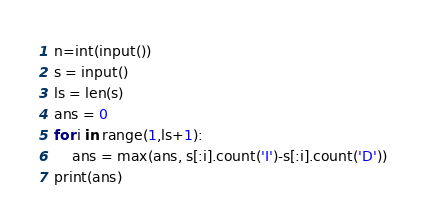<code> <loc_0><loc_0><loc_500><loc_500><_Python_>n=int(input())
s = input()
ls = len(s)
ans = 0
for i in range(1,ls+1):
    ans = max(ans, s[:i].count('I')-s[:i].count('D'))
print(ans)</code> 